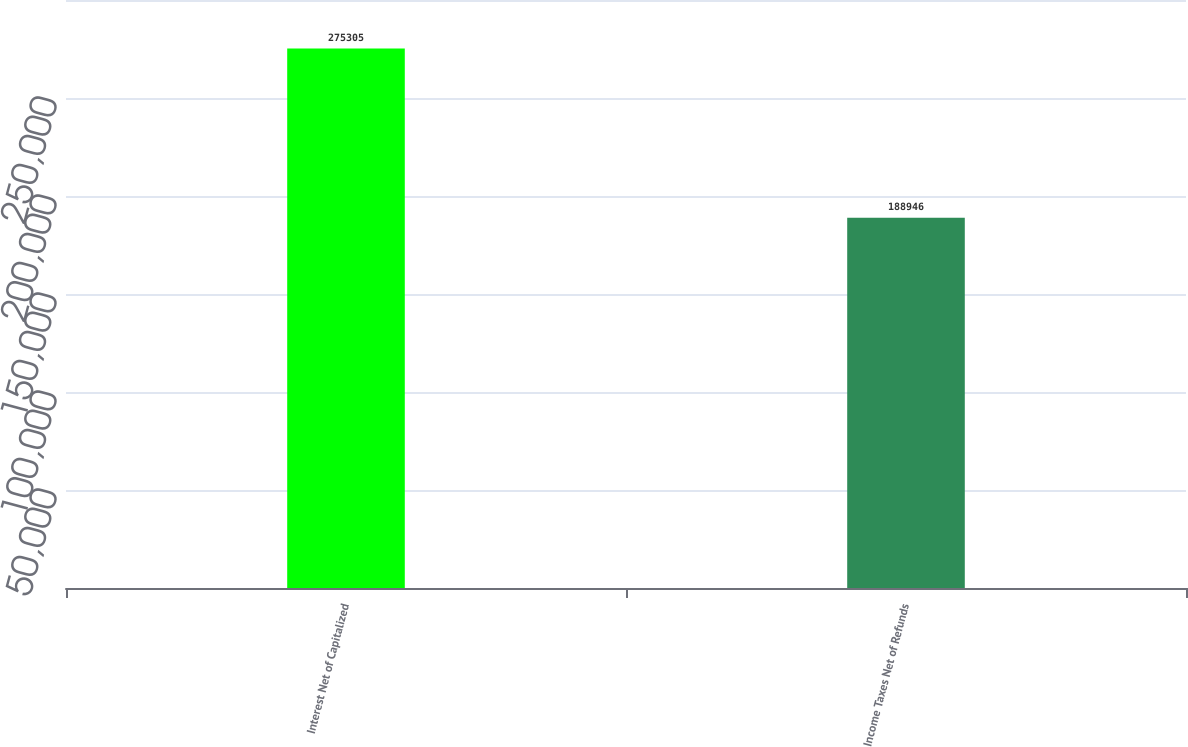<chart> <loc_0><loc_0><loc_500><loc_500><bar_chart><fcel>Interest Net of Capitalized<fcel>Income Taxes Net of Refunds<nl><fcel>275305<fcel>188946<nl></chart> 